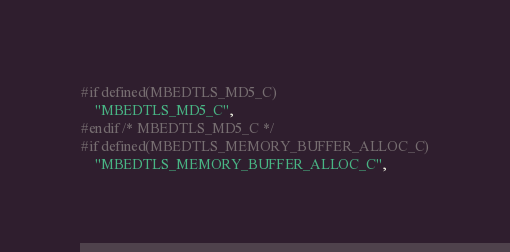<code> <loc_0><loc_0><loc_500><loc_500><_C_>#if defined(MBEDTLS_MD5_C)
    "MBEDTLS_MD5_C",
#endif /* MBEDTLS_MD5_C */
#if defined(MBEDTLS_MEMORY_BUFFER_ALLOC_C)
    "MBEDTLS_MEMORY_BUFFER_ALLOC_C",</code> 